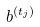Convert formula to latex. <formula><loc_0><loc_0><loc_500><loc_500>b ^ { ( t _ { j } ) }</formula> 